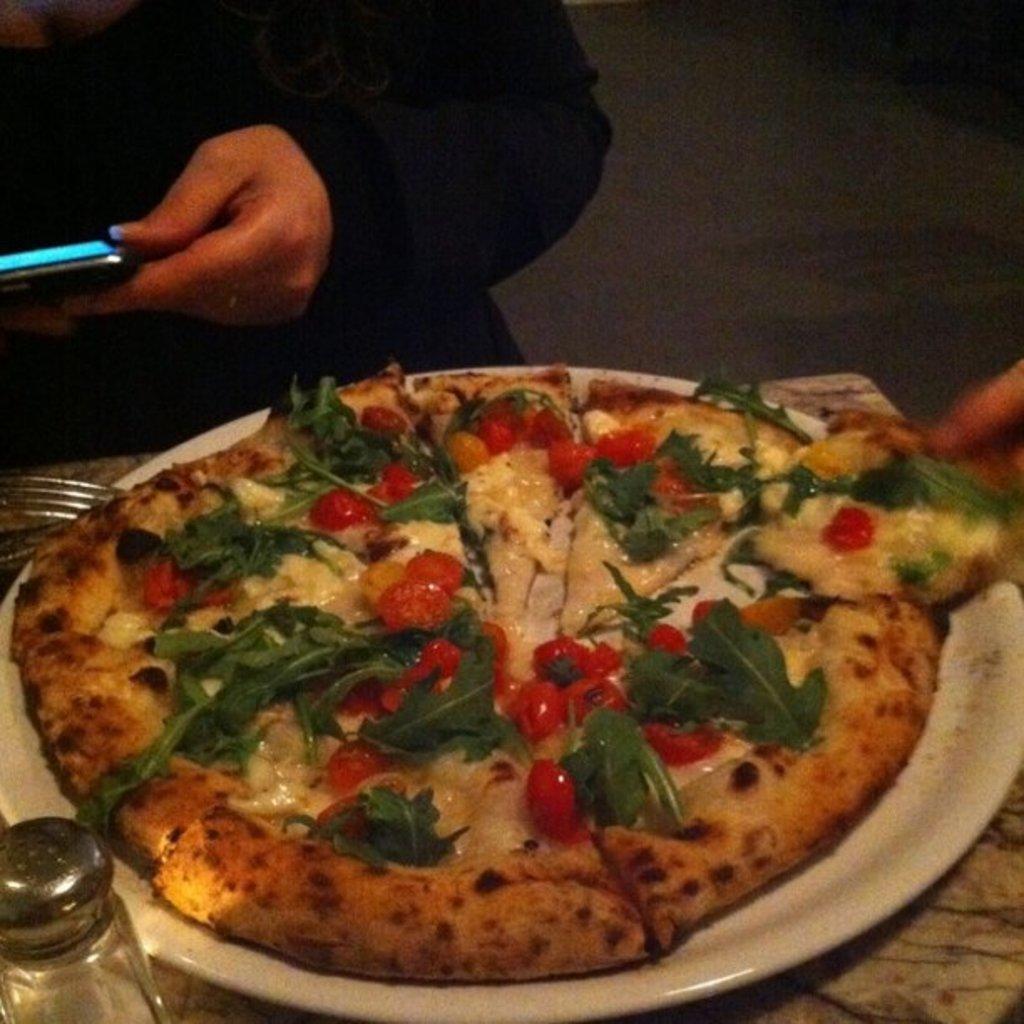Can you describe this image briefly? In this image, we can see a pizza is placed on the white plate. Left side of the image, we can see a container and fork. These items are placed on the surface. Top of the image, there is a human is holding a mobile. 